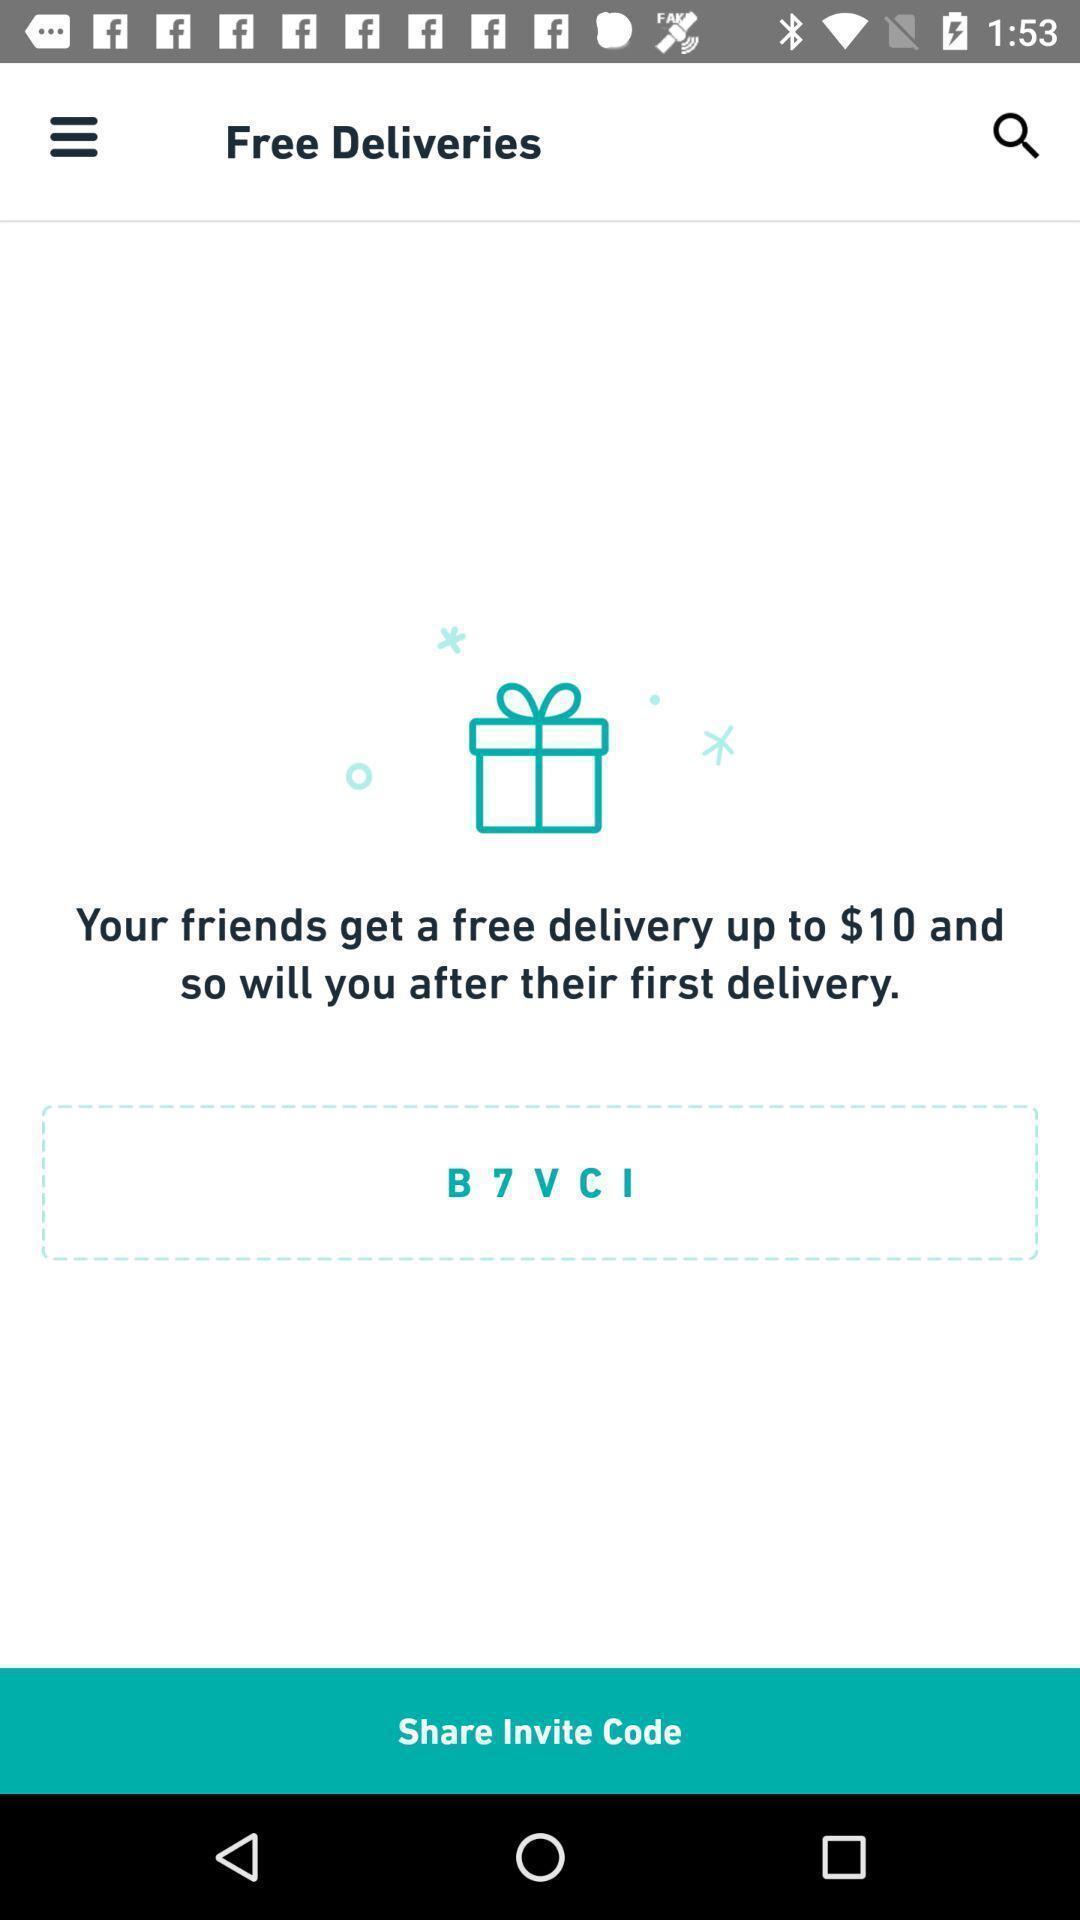Summarize the information in this screenshot. Page to share invite code for the deliveries app. 